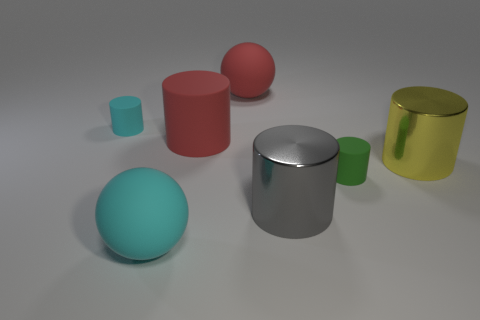How many objects are tiny matte cylinders that are behind the large yellow metallic thing or big cyan balls?
Your response must be concise. 2. There is a large red rubber thing behind the small rubber cylinder that is behind the big red rubber cylinder that is behind the cyan sphere; what is its shape?
Give a very brief answer. Sphere. How many gray metallic objects are the same shape as the large cyan thing?
Make the answer very short. 0. Are the big yellow object and the large cyan sphere made of the same material?
Your answer should be very brief. No. How many big rubber spheres are in front of the big object behind the small cyan rubber object that is to the left of the large yellow metal thing?
Your answer should be compact. 1. Is there a big purple ball made of the same material as the large yellow cylinder?
Keep it short and to the point. No. What size is the rubber ball that is the same color as the large matte cylinder?
Your answer should be very brief. Large. Is the number of shiny objects less than the number of small shiny spheres?
Ensure brevity in your answer.  No. Is the color of the matte sphere behind the tiny green matte thing the same as the large rubber cylinder?
Make the answer very short. Yes. What material is the cyan object left of the cyan rubber object on the right side of the small rubber cylinder to the left of the big gray cylinder?
Your response must be concise. Rubber. 